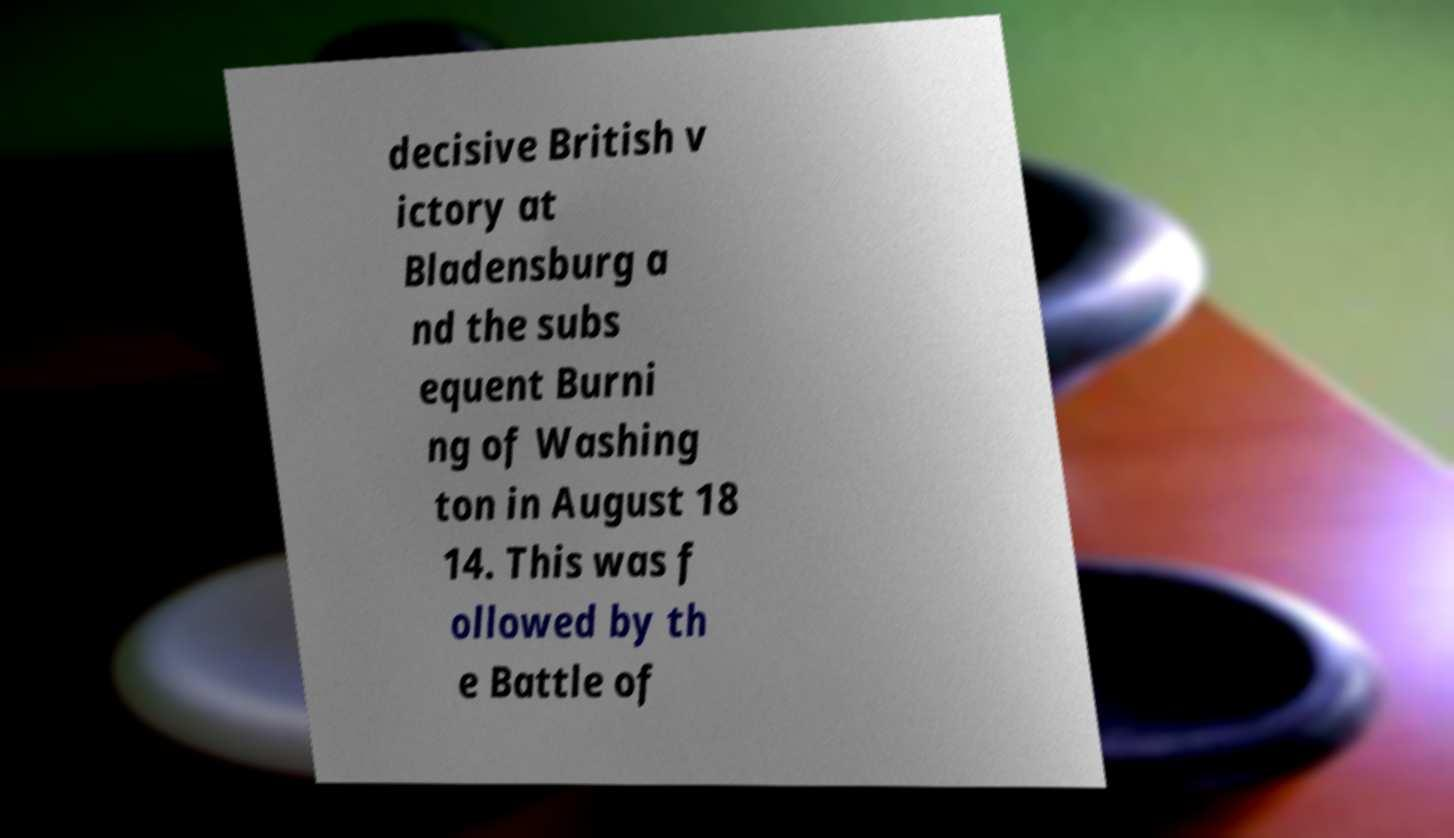There's text embedded in this image that I need extracted. Can you transcribe it verbatim? decisive British v ictory at Bladensburg a nd the subs equent Burni ng of Washing ton in August 18 14. This was f ollowed by th e Battle of 